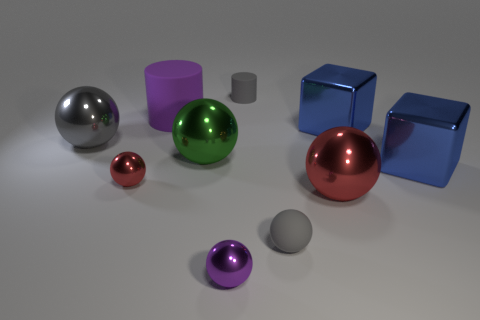Subtract all red spheres. How many spheres are left? 4 Subtract all tiny purple shiny spheres. How many spheres are left? 5 Subtract all green spheres. Subtract all purple blocks. How many spheres are left? 5 Subtract all balls. How many objects are left? 4 Subtract 0 yellow cylinders. How many objects are left? 10 Subtract all gray metallic objects. Subtract all large gray shiny things. How many objects are left? 8 Add 2 matte balls. How many matte balls are left? 3 Add 1 gray metallic spheres. How many gray metallic spheres exist? 2 